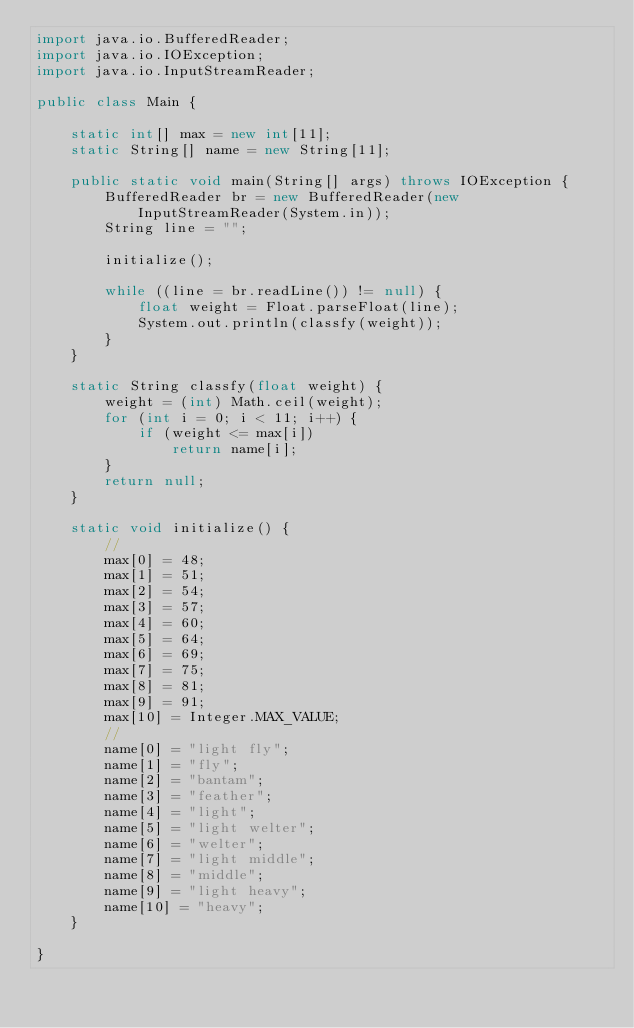Convert code to text. <code><loc_0><loc_0><loc_500><loc_500><_Java_>import java.io.BufferedReader;
import java.io.IOException;
import java.io.InputStreamReader;

public class Main {

	static int[] max = new int[11];
	static String[] name = new String[11];

	public static void main(String[] args) throws IOException {
		BufferedReader br = new BufferedReader(new InputStreamReader(System.in));
		String line = "";

		initialize();

		while ((line = br.readLine()) != null) {
			float weight = Float.parseFloat(line);
			System.out.println(classfy(weight));
		}
	}

	static String classfy(float weight) {
		weight = (int) Math.ceil(weight);
		for (int i = 0; i < 11; i++) {
			if (weight <= max[i])
				return name[i];
		}
		return null;
	}

	static void initialize() {
		//
		max[0] = 48;
		max[1] = 51;
		max[2] = 54;
		max[3] = 57;
		max[4] = 60;
		max[5] = 64;
		max[6] = 69;
		max[7] = 75;
		max[8] = 81;
		max[9] = 91;
		max[10] = Integer.MAX_VALUE;
		//
		name[0] = "light fly";
		name[1] = "fly";
		name[2] = "bantam";
		name[3] = "feather";
		name[4] = "light";
		name[5] = "light welter";
		name[6] = "welter";
		name[7] = "light middle";
		name[8] = "middle";
		name[9] = "light heavy";
		name[10] = "heavy";
	}

}</code> 